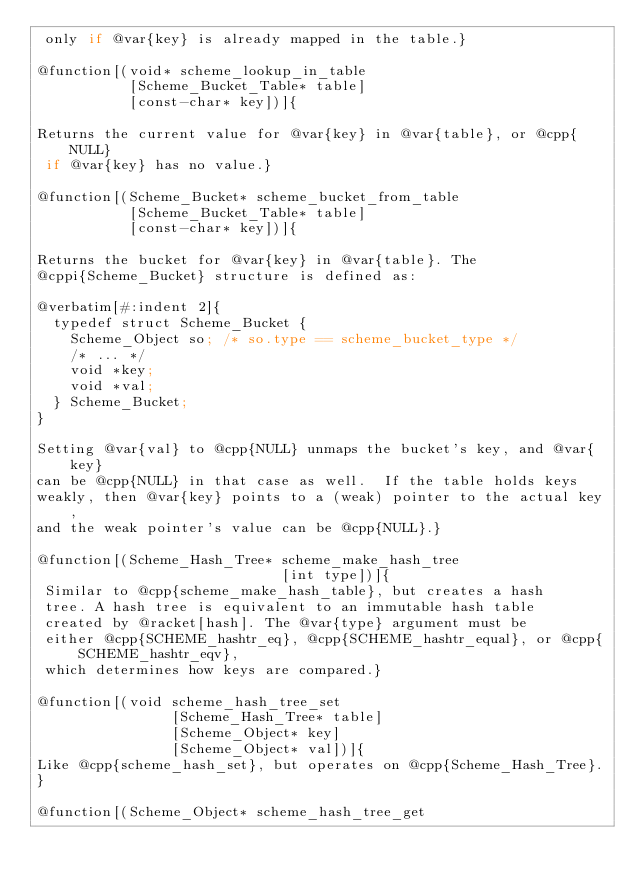<code> <loc_0><loc_0><loc_500><loc_500><_Racket_> only if @var{key} is already mapped in the table.}

@function[(void* scheme_lookup_in_table
           [Scheme_Bucket_Table* table]
           [const-char* key])]{

Returns the current value for @var{key} in @var{table}, or @cpp{NULL}
 if @var{key} has no value.}

@function[(Scheme_Bucket* scheme_bucket_from_table
           [Scheme_Bucket_Table* table]
           [const-char* key])]{

Returns the bucket for @var{key} in @var{table}. The
@cppi{Scheme_Bucket} structure is defined as:

@verbatim[#:indent 2]{
  typedef struct Scheme_Bucket {
    Scheme_Object so; /* so.type == scheme_bucket_type */
    /* ... */
    void *key;
    void *val;
  } Scheme_Bucket;
}

Setting @var{val} to @cpp{NULL} unmaps the bucket's key, and @var{key}
can be @cpp{NULL} in that case as well.  If the table holds keys
weakly, then @var{key} points to a (weak) pointer to the actual key,
and the weak pointer's value can be @cpp{NULL}.}

@function[(Scheme_Hash_Tree* scheme_make_hash_tree
                             [int type])]{
 Similar to @cpp{scheme_make_hash_table}, but creates a hash
 tree. A hash tree is equivalent to an immutable hash table
 created by @racket[hash]. The @var{type} argument must be
 either @cpp{SCHEME_hashtr_eq}, @cpp{SCHEME_hashtr_equal}, or @cpp{SCHEME_hashtr_eqv},
 which determines how keys are compared.}

@function[(void scheme_hash_tree_set
                [Scheme_Hash_Tree* table]
                [Scheme_Object* key]
                [Scheme_Object* val])]{
Like @cpp{scheme_hash_set}, but operates on @cpp{Scheme_Hash_Tree}.
}

@function[(Scheme_Object* scheme_hash_tree_get</code> 